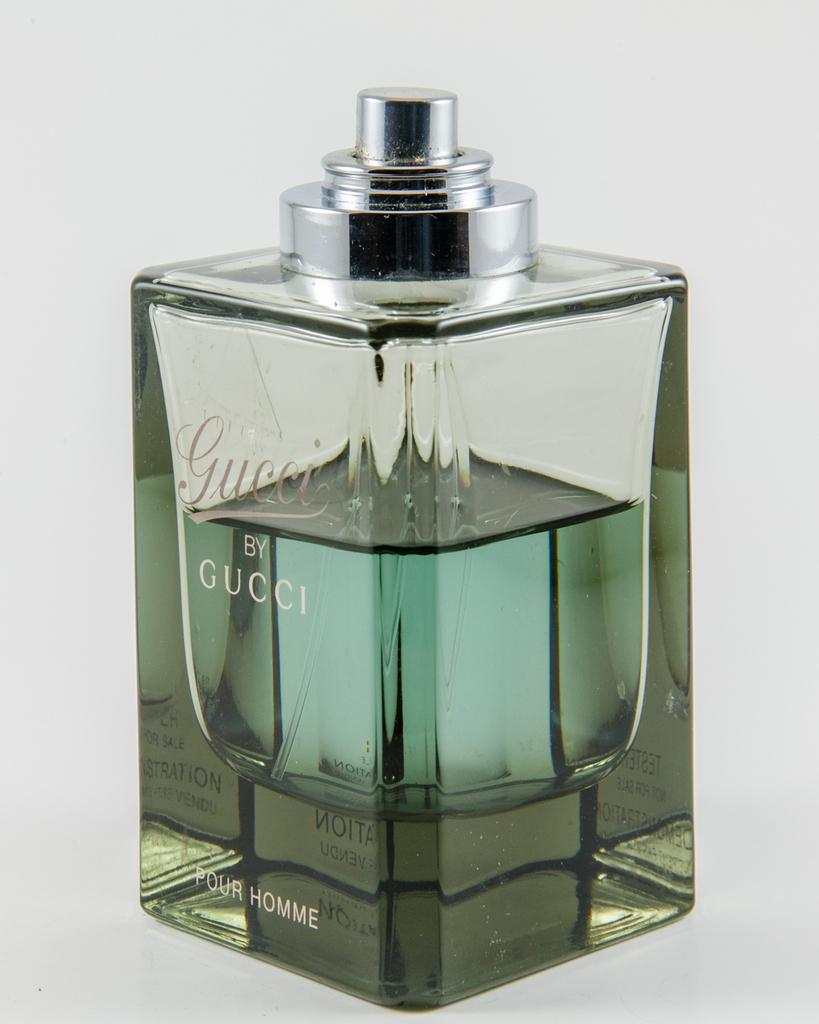Provide a one-sentence caption for the provided image. A bottle of Gucci by Gucci cologne sits on a table. 